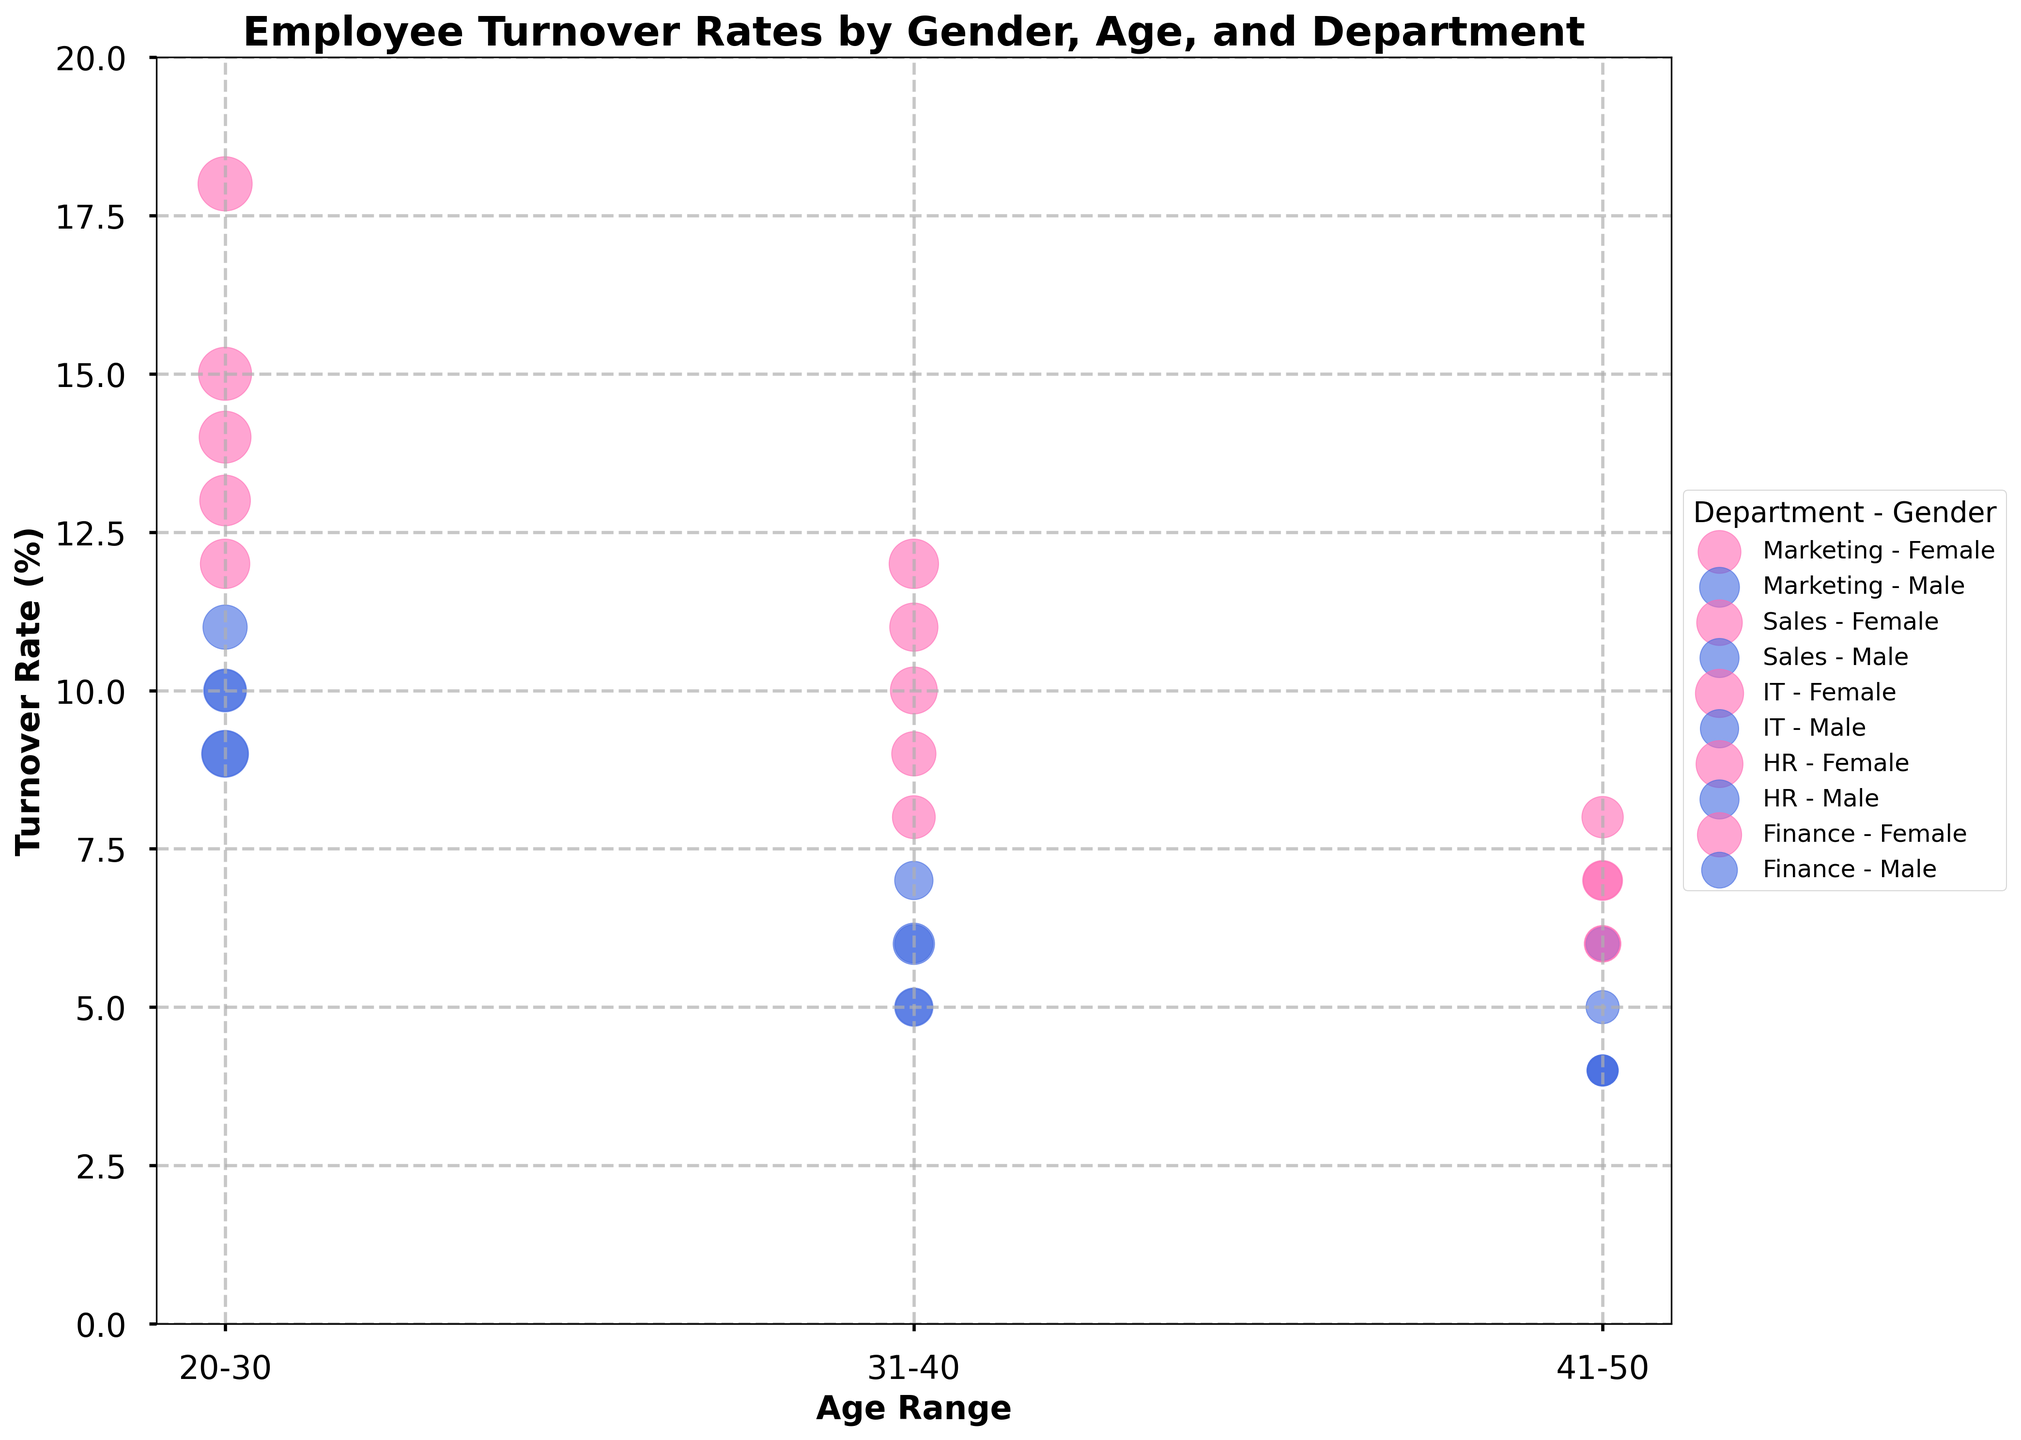What is the title of the figure? The title is typically located at the top of the figure, and it generally summarizes the main takeaway or focus of the plot. In this case, the title given in the code is "Employee Turnover Rates by Gender, Age, and Department."
Answer: Employee Turnover Rates by Gender, Age, and Department What does the x-axis represent? The x-axis generally represents a variable that is to be compared across various categories. According to the code, the x-axis shows "Age Range."
Answer: Age Range Which department has the highest turnover rate for females aged 20-30? By looking at the bubbles corresponding to females aged 20-30, we identify the one with the highest position on the y-axis. According to the data, the IT department has the highest turnover rate of 18% for females aged 20-30.
Answer: IT In which department do males aged 31-40 have the lowest turnover rate? By analyzing the position of the bubbles corresponding to males aged 31-40, we identify the department with the lowest position on the y-axis. According to the data, males aged 31-40 in the Finance department have the lowest turnover rate of 6%.
Answer: Finance Compare the turnover rates between males and females aged 20-30 in the Marketing department. Who has the higher rate? By comparing the positions of the bubbles for males and females aged 20-30 in Marketing, we note the y-axis values. Females aged 20-30 have a turnover rate of 12%, and males have a turnover rate of 9%. Thus, females have a higher turnover rate.
Answer: Females What's the average turnover rate for females in the Sales department across all age ranges? First, identify the bubbles for females in the Sales department, then find the turnover rates: 14%, 10%, and 7%. Calculate the average by summing these values and dividing by the number of values. (14 + 10 + 7) / 3 = 31 / 3 = 10.33
Answer: 10.33 Which age range has the largest bubble size for females in the IT department? Look for the bubble with the largest area, which signifies the largest bubble size, in the IT department for females across age ranges. For females, the bubble sizes are 24, 20, and 14. The largest size is 24, corresponding to the 20-30 age range.
Answer: 20-30 What is the turnover rate difference between males and females aged 41-50 in the HR department? Identify the bubbles for males and females aged 41-50 in HR. The turnover rates are 7% for females and 4% for males. Calculate the difference: 7% - 4% = 3%.
Answer: 3% How does the turnover rate for males aged 20-30 in Finance compare to the same group in Sales? Compare the y-axis positions for males aged 20-30 in Finance and Sales. The turnover rates are 10% for Finance and 11% for Sales. Thus, the rate is lower in Finance.
Answer: Lower in Finance 